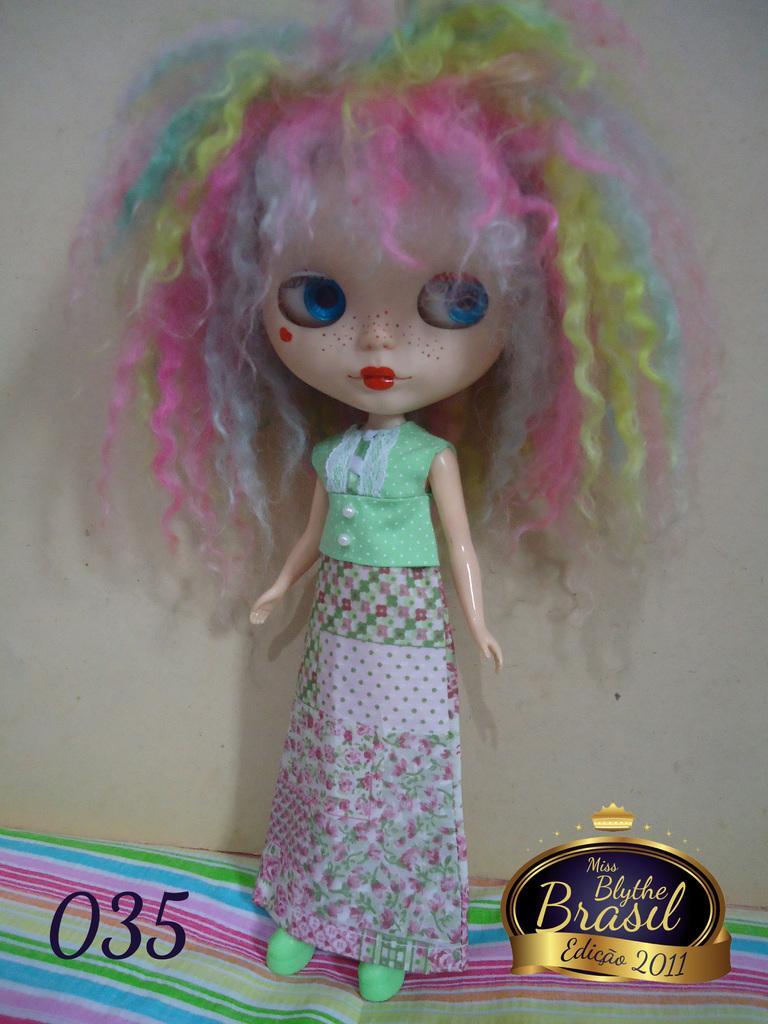Describe this image in one or two sentences. In this image we can see a doll. We can also see a wall. On the bottom of the image we can see some numbers and a logo. 